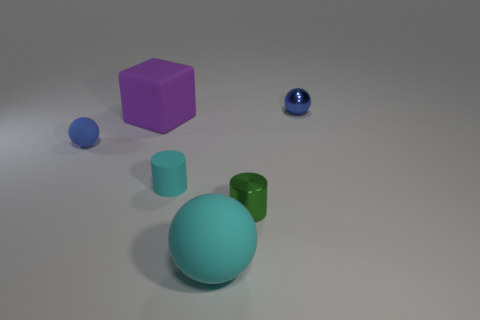Is the number of large purple rubber objects that are in front of the big cyan rubber sphere less than the number of balls in front of the matte cube?
Keep it short and to the point. Yes. The big matte object in front of the green shiny thing has what shape?
Ensure brevity in your answer.  Sphere. What is the material of the object that is the same color as the small matte sphere?
Provide a succinct answer. Metal. How many other things are there of the same material as the big cyan ball?
Your answer should be compact. 3. Do the green shiny thing and the cyan matte thing behind the large cyan rubber thing have the same shape?
Make the answer very short. Yes. What is the shape of the tiny blue thing that is made of the same material as the cyan sphere?
Ensure brevity in your answer.  Sphere. Is the number of tiny rubber objects in front of the large ball greater than the number of small cyan cylinders on the right side of the small green metallic object?
Your answer should be compact. No. How many things are either large cyan spheres or balls?
Your response must be concise. 3. How many other things are the same color as the matte cylinder?
Your answer should be compact. 1. What is the shape of the cyan object that is the same size as the purple matte cube?
Your answer should be very brief. Sphere. 